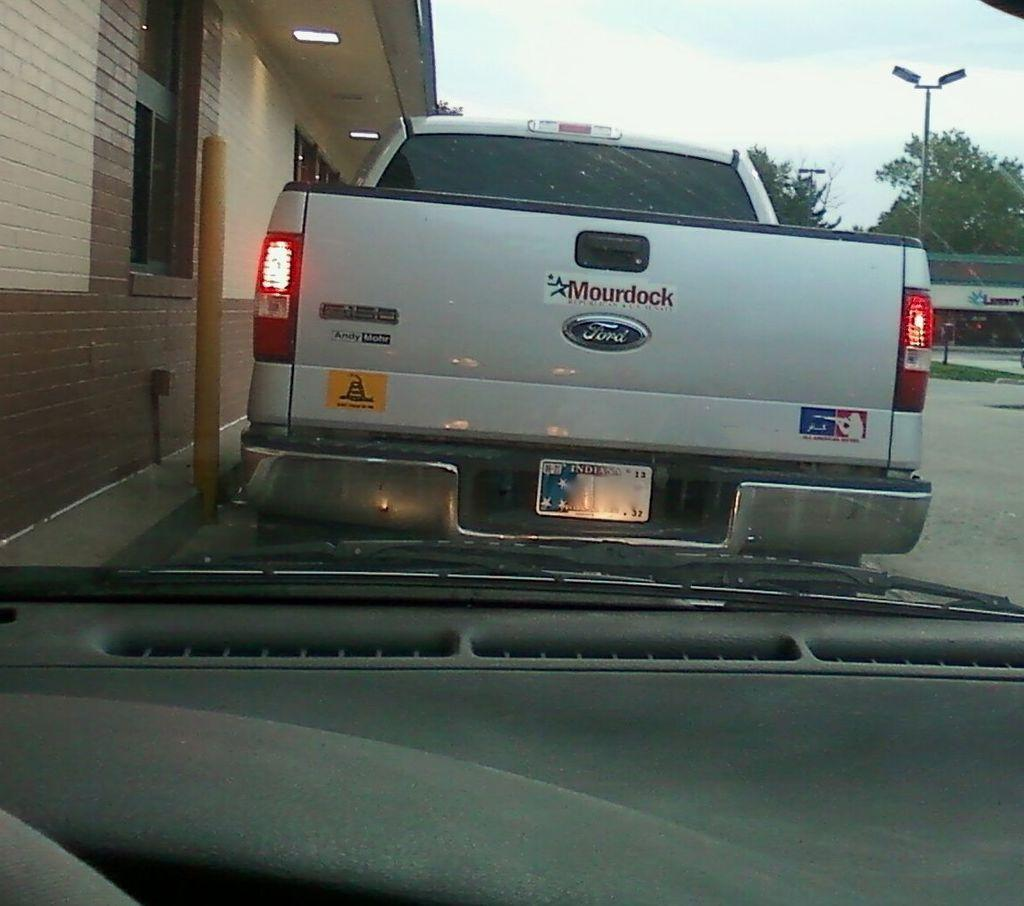<image>
Describe the image concisely. A pickup truck has a sticker that says Mourdock on it. 